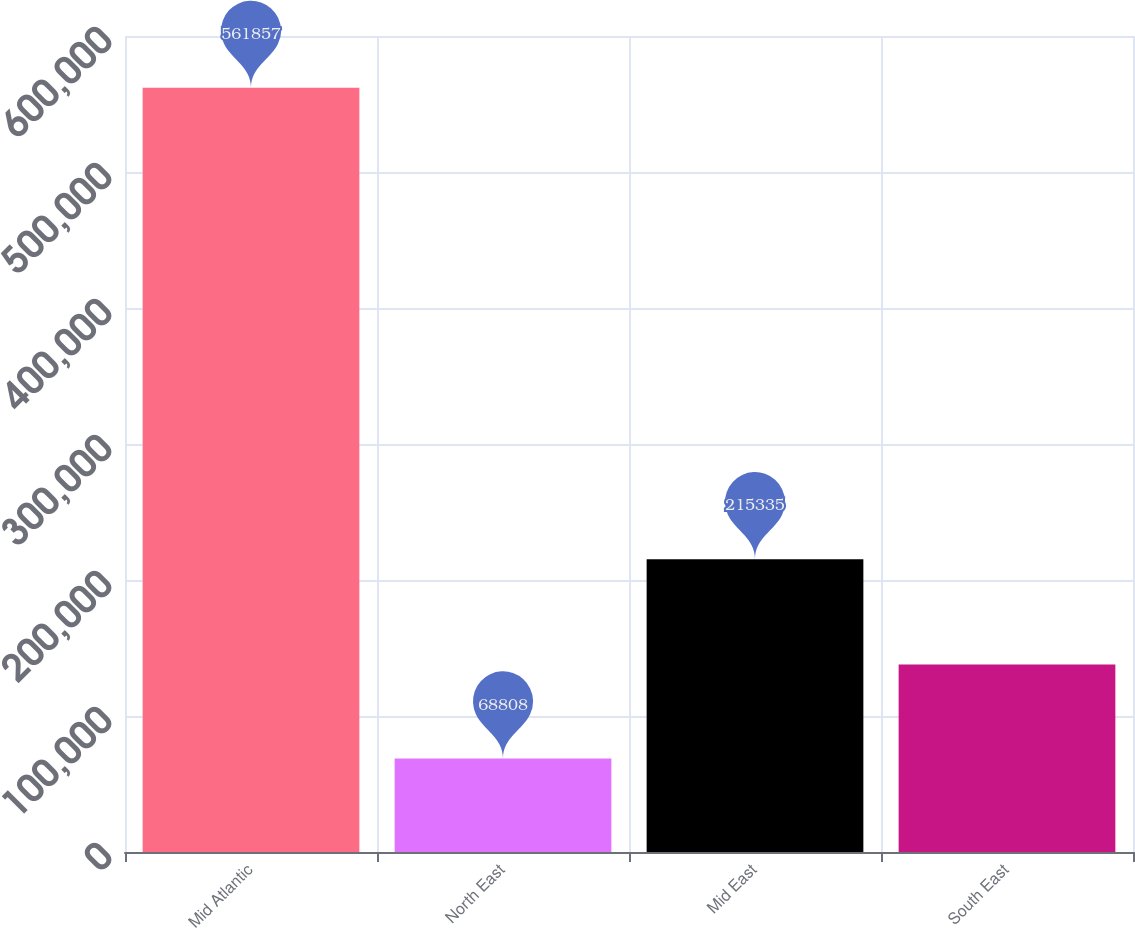<chart> <loc_0><loc_0><loc_500><loc_500><bar_chart><fcel>Mid Atlantic<fcel>North East<fcel>Mid East<fcel>South East<nl><fcel>561857<fcel>68808<fcel>215335<fcel>137787<nl></chart> 